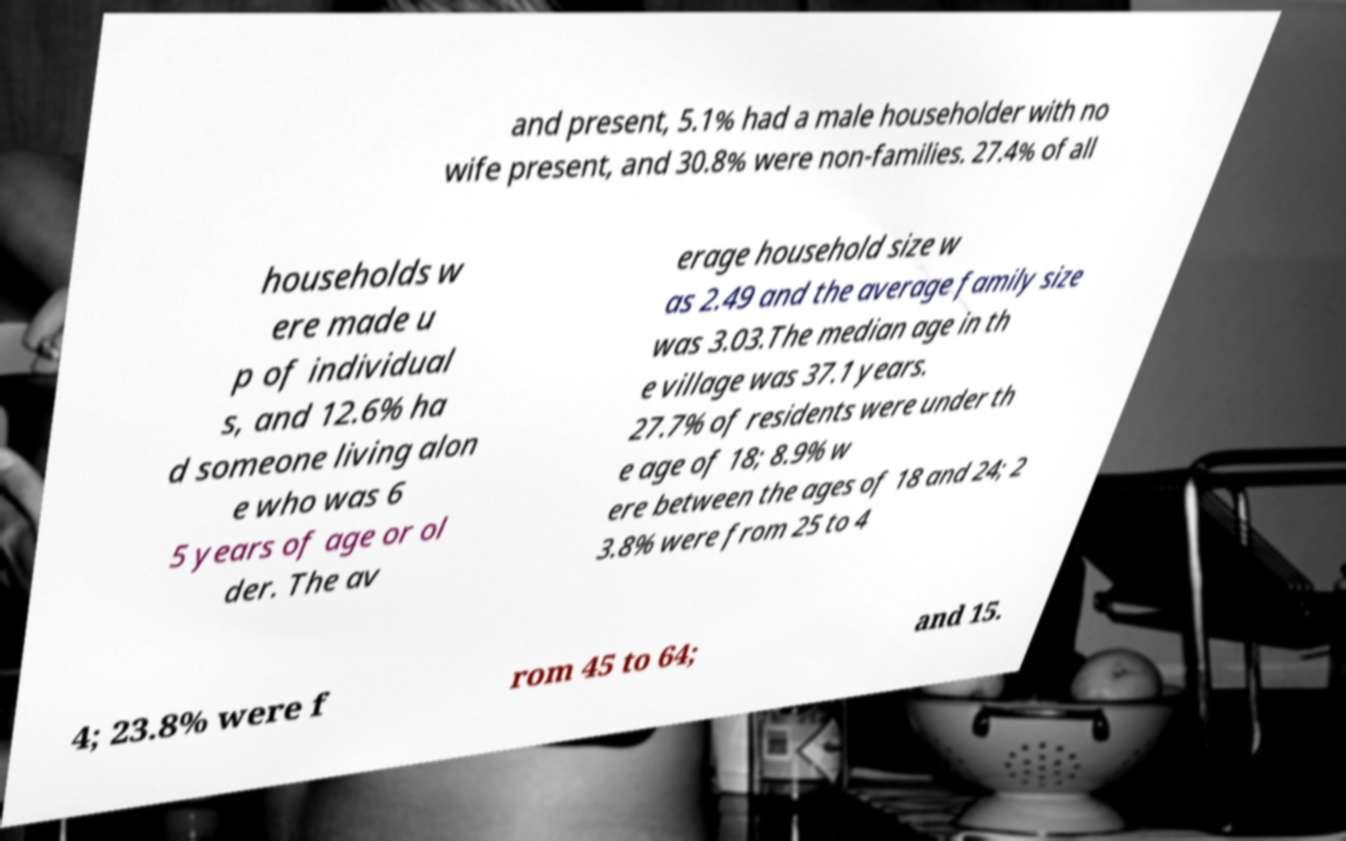There's text embedded in this image that I need extracted. Can you transcribe it verbatim? and present, 5.1% had a male householder with no wife present, and 30.8% were non-families. 27.4% of all households w ere made u p of individual s, and 12.6% ha d someone living alon e who was 6 5 years of age or ol der. The av erage household size w as 2.49 and the average family size was 3.03.The median age in th e village was 37.1 years. 27.7% of residents were under th e age of 18; 8.9% w ere between the ages of 18 and 24; 2 3.8% were from 25 to 4 4; 23.8% were f rom 45 to 64; and 15. 